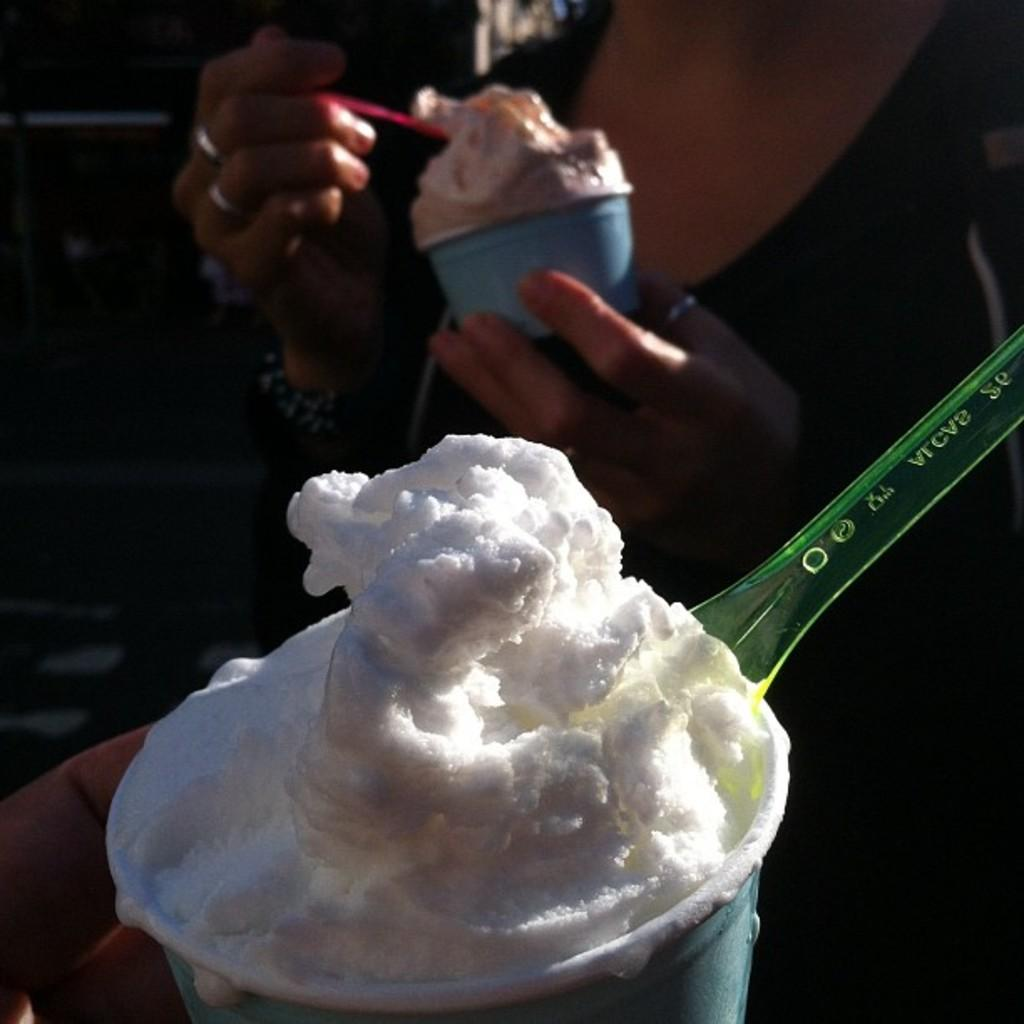What is the main subject of the picture? The main subject of the picture is an ice cream cup. What is unique about the ice cream cup? The ice cream cup has a spoon at the bottom. Can you describe the human presence in the image? There is a human hand visible on the left side of the image, and a person is holding the ice cream cup with their hands. What time of day is it in the image, and can you see a snail on the ice cream cup? The time of day cannot be determined from the image, and there is no snail present on the ice cream cup. What type of drink is being consumed in the image? The image does not depict a drink being consumed; it features an ice cream cup. 